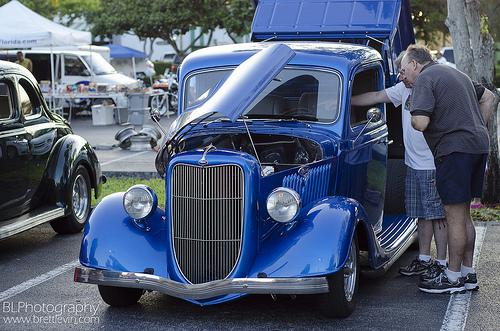Question: what color is the bus?
Choices:
A. Magneta.
B. Purple.
C. Royal blue.
D. Yellow.
Answer with the letter. Answer: C Question: where is this location?
Choices:
A. A coffee shop.
B. A pub.
C. A car dealership.
D. An auto show.
Answer with the letter. Answer: D Question: who is attending the show?
Choices:
A. Enthusiasts.
B. Fans.
C. Students.
D. Specials guests.
Answer with the letter. Answer: A Question: what is in the background?
Choices:
A. Ocean.
B. Christmas tree.
C. Church.
D. Trees and a van.
Answer with the letter. Answer: D Question: how detailed is the truck?
Choices:
A. Somewhat detailed.
B. Not very detailed.
C. Very detailed.
D. Professionally detailed.
Answer with the letter. Answer: C 